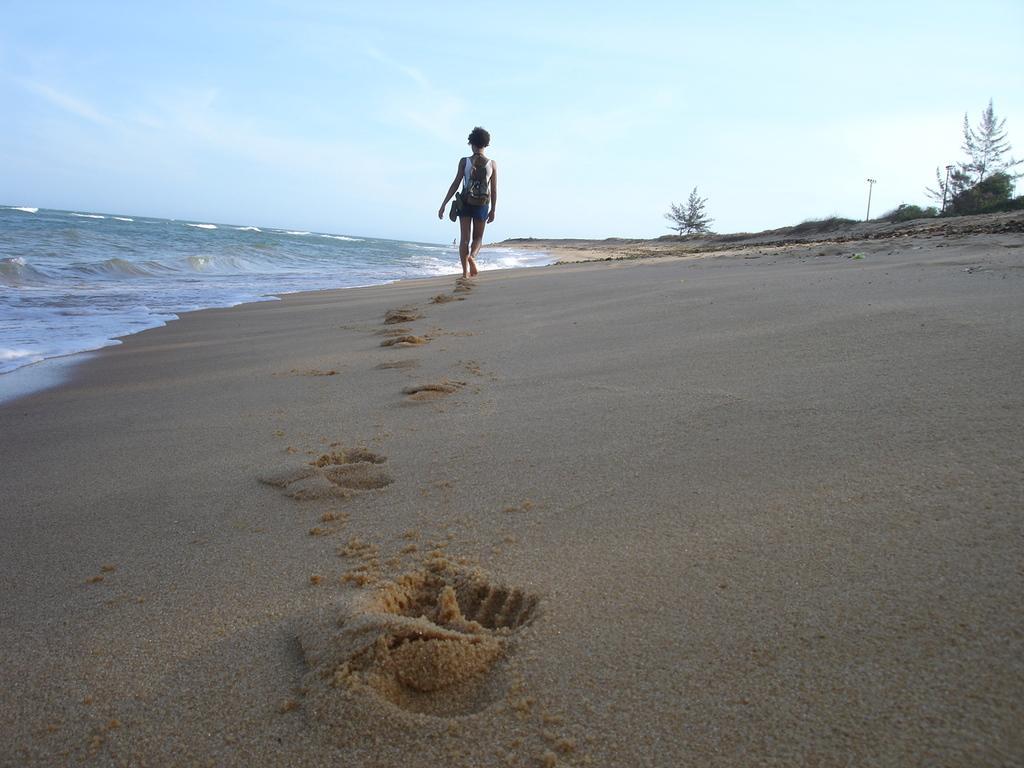Describe this image in one or two sentences. In this image I can see footsteps of a person on the sand. There is a person in the center. There is water on the left and there are few trees and a pole at the back. There is sky at the top. 